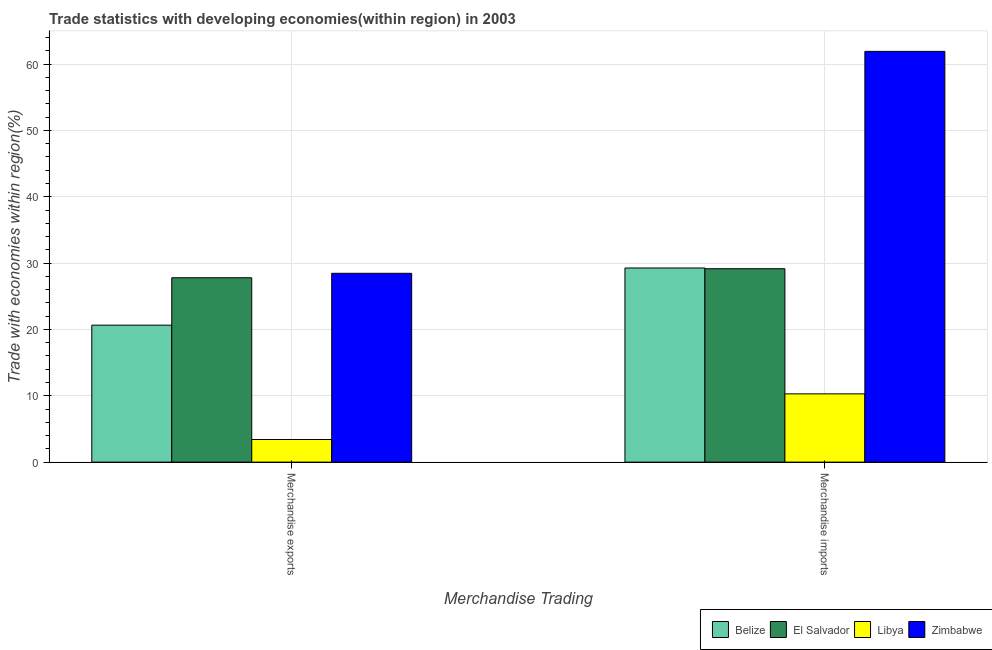How many different coloured bars are there?
Ensure brevity in your answer.  4. Are the number of bars per tick equal to the number of legend labels?
Provide a succinct answer. Yes. How many bars are there on the 1st tick from the left?
Your response must be concise. 4. How many bars are there on the 2nd tick from the right?
Your answer should be very brief. 4. What is the label of the 1st group of bars from the left?
Offer a very short reply. Merchandise exports. What is the merchandise exports in Libya?
Your answer should be very brief. 3.41. Across all countries, what is the maximum merchandise imports?
Offer a very short reply. 61.91. Across all countries, what is the minimum merchandise imports?
Give a very brief answer. 10.29. In which country was the merchandise exports maximum?
Provide a short and direct response. Zimbabwe. In which country was the merchandise exports minimum?
Provide a short and direct response. Libya. What is the total merchandise imports in the graph?
Your response must be concise. 130.61. What is the difference between the merchandise imports in Zimbabwe and that in El Salvador?
Provide a succinct answer. 32.76. What is the difference between the merchandise imports in El Salvador and the merchandise exports in Belize?
Make the answer very short. 8.51. What is the average merchandise imports per country?
Keep it short and to the point. 32.65. What is the difference between the merchandise imports and merchandise exports in Belize?
Offer a terse response. 8.62. What is the ratio of the merchandise imports in Libya to that in El Salvador?
Offer a terse response. 0.35. What does the 3rd bar from the left in Merchandise imports represents?
Offer a terse response. Libya. What does the 3rd bar from the right in Merchandise exports represents?
Offer a very short reply. El Salvador. How many bars are there?
Give a very brief answer. 8. What is the difference between two consecutive major ticks on the Y-axis?
Ensure brevity in your answer.  10. Does the graph contain any zero values?
Your answer should be very brief. No. Where does the legend appear in the graph?
Provide a short and direct response. Bottom right. How are the legend labels stacked?
Your answer should be compact. Horizontal. What is the title of the graph?
Ensure brevity in your answer.  Trade statistics with developing economies(within region) in 2003. Does "Puerto Rico" appear as one of the legend labels in the graph?
Your answer should be very brief. No. What is the label or title of the X-axis?
Your answer should be very brief. Merchandise Trading. What is the label or title of the Y-axis?
Provide a succinct answer. Trade with economies within region(%). What is the Trade with economies within region(%) in Belize in Merchandise exports?
Keep it short and to the point. 20.64. What is the Trade with economies within region(%) of El Salvador in Merchandise exports?
Provide a short and direct response. 27.79. What is the Trade with economies within region(%) in Libya in Merchandise exports?
Give a very brief answer. 3.41. What is the Trade with economies within region(%) of Zimbabwe in Merchandise exports?
Provide a short and direct response. 28.46. What is the Trade with economies within region(%) of Belize in Merchandise imports?
Provide a short and direct response. 29.26. What is the Trade with economies within region(%) in El Salvador in Merchandise imports?
Offer a terse response. 29.15. What is the Trade with economies within region(%) of Libya in Merchandise imports?
Ensure brevity in your answer.  10.29. What is the Trade with economies within region(%) in Zimbabwe in Merchandise imports?
Your response must be concise. 61.91. Across all Merchandise Trading, what is the maximum Trade with economies within region(%) of Belize?
Offer a very short reply. 29.26. Across all Merchandise Trading, what is the maximum Trade with economies within region(%) in El Salvador?
Your answer should be compact. 29.15. Across all Merchandise Trading, what is the maximum Trade with economies within region(%) in Libya?
Ensure brevity in your answer.  10.29. Across all Merchandise Trading, what is the maximum Trade with economies within region(%) of Zimbabwe?
Offer a terse response. 61.91. Across all Merchandise Trading, what is the minimum Trade with economies within region(%) in Belize?
Make the answer very short. 20.64. Across all Merchandise Trading, what is the minimum Trade with economies within region(%) of El Salvador?
Ensure brevity in your answer.  27.79. Across all Merchandise Trading, what is the minimum Trade with economies within region(%) in Libya?
Keep it short and to the point. 3.41. Across all Merchandise Trading, what is the minimum Trade with economies within region(%) of Zimbabwe?
Your answer should be compact. 28.46. What is the total Trade with economies within region(%) of Belize in the graph?
Keep it short and to the point. 49.9. What is the total Trade with economies within region(%) of El Salvador in the graph?
Make the answer very short. 56.94. What is the total Trade with economies within region(%) of Libya in the graph?
Ensure brevity in your answer.  13.7. What is the total Trade with economies within region(%) in Zimbabwe in the graph?
Provide a succinct answer. 90.37. What is the difference between the Trade with economies within region(%) in Belize in Merchandise exports and that in Merchandise imports?
Your response must be concise. -8.62. What is the difference between the Trade with economies within region(%) in El Salvador in Merchandise exports and that in Merchandise imports?
Offer a very short reply. -1.36. What is the difference between the Trade with economies within region(%) in Libya in Merchandise exports and that in Merchandise imports?
Make the answer very short. -6.88. What is the difference between the Trade with economies within region(%) in Zimbabwe in Merchandise exports and that in Merchandise imports?
Make the answer very short. -33.45. What is the difference between the Trade with economies within region(%) of Belize in Merchandise exports and the Trade with economies within region(%) of El Salvador in Merchandise imports?
Give a very brief answer. -8.51. What is the difference between the Trade with economies within region(%) in Belize in Merchandise exports and the Trade with economies within region(%) in Libya in Merchandise imports?
Your answer should be compact. 10.36. What is the difference between the Trade with economies within region(%) of Belize in Merchandise exports and the Trade with economies within region(%) of Zimbabwe in Merchandise imports?
Provide a short and direct response. -41.27. What is the difference between the Trade with economies within region(%) of El Salvador in Merchandise exports and the Trade with economies within region(%) of Libya in Merchandise imports?
Keep it short and to the point. 17.5. What is the difference between the Trade with economies within region(%) of El Salvador in Merchandise exports and the Trade with economies within region(%) of Zimbabwe in Merchandise imports?
Offer a very short reply. -34.12. What is the difference between the Trade with economies within region(%) in Libya in Merchandise exports and the Trade with economies within region(%) in Zimbabwe in Merchandise imports?
Ensure brevity in your answer.  -58.5. What is the average Trade with economies within region(%) of Belize per Merchandise Trading?
Offer a terse response. 24.95. What is the average Trade with economies within region(%) in El Salvador per Merchandise Trading?
Make the answer very short. 28.47. What is the average Trade with economies within region(%) of Libya per Merchandise Trading?
Your response must be concise. 6.85. What is the average Trade with economies within region(%) in Zimbabwe per Merchandise Trading?
Ensure brevity in your answer.  45.19. What is the difference between the Trade with economies within region(%) in Belize and Trade with economies within region(%) in El Salvador in Merchandise exports?
Your answer should be very brief. -7.15. What is the difference between the Trade with economies within region(%) of Belize and Trade with economies within region(%) of Libya in Merchandise exports?
Your answer should be compact. 17.23. What is the difference between the Trade with economies within region(%) of Belize and Trade with economies within region(%) of Zimbabwe in Merchandise exports?
Your response must be concise. -7.82. What is the difference between the Trade with economies within region(%) in El Salvador and Trade with economies within region(%) in Libya in Merchandise exports?
Your answer should be compact. 24.38. What is the difference between the Trade with economies within region(%) in El Salvador and Trade with economies within region(%) in Zimbabwe in Merchandise exports?
Provide a short and direct response. -0.67. What is the difference between the Trade with economies within region(%) of Libya and Trade with economies within region(%) of Zimbabwe in Merchandise exports?
Give a very brief answer. -25.05. What is the difference between the Trade with economies within region(%) of Belize and Trade with economies within region(%) of El Salvador in Merchandise imports?
Provide a short and direct response. 0.11. What is the difference between the Trade with economies within region(%) in Belize and Trade with economies within region(%) in Libya in Merchandise imports?
Provide a succinct answer. 18.97. What is the difference between the Trade with economies within region(%) in Belize and Trade with economies within region(%) in Zimbabwe in Merchandise imports?
Make the answer very short. -32.65. What is the difference between the Trade with economies within region(%) of El Salvador and Trade with economies within region(%) of Libya in Merchandise imports?
Provide a short and direct response. 18.86. What is the difference between the Trade with economies within region(%) of El Salvador and Trade with economies within region(%) of Zimbabwe in Merchandise imports?
Keep it short and to the point. -32.76. What is the difference between the Trade with economies within region(%) of Libya and Trade with economies within region(%) of Zimbabwe in Merchandise imports?
Keep it short and to the point. -51.62. What is the ratio of the Trade with economies within region(%) in Belize in Merchandise exports to that in Merchandise imports?
Make the answer very short. 0.71. What is the ratio of the Trade with economies within region(%) of El Salvador in Merchandise exports to that in Merchandise imports?
Your answer should be very brief. 0.95. What is the ratio of the Trade with economies within region(%) of Libya in Merchandise exports to that in Merchandise imports?
Provide a succinct answer. 0.33. What is the ratio of the Trade with economies within region(%) in Zimbabwe in Merchandise exports to that in Merchandise imports?
Provide a short and direct response. 0.46. What is the difference between the highest and the second highest Trade with economies within region(%) in Belize?
Make the answer very short. 8.62. What is the difference between the highest and the second highest Trade with economies within region(%) in El Salvador?
Ensure brevity in your answer.  1.36. What is the difference between the highest and the second highest Trade with economies within region(%) in Libya?
Give a very brief answer. 6.88. What is the difference between the highest and the second highest Trade with economies within region(%) of Zimbabwe?
Make the answer very short. 33.45. What is the difference between the highest and the lowest Trade with economies within region(%) of Belize?
Give a very brief answer. 8.62. What is the difference between the highest and the lowest Trade with economies within region(%) of El Salvador?
Ensure brevity in your answer.  1.36. What is the difference between the highest and the lowest Trade with economies within region(%) of Libya?
Provide a short and direct response. 6.88. What is the difference between the highest and the lowest Trade with economies within region(%) of Zimbabwe?
Offer a terse response. 33.45. 